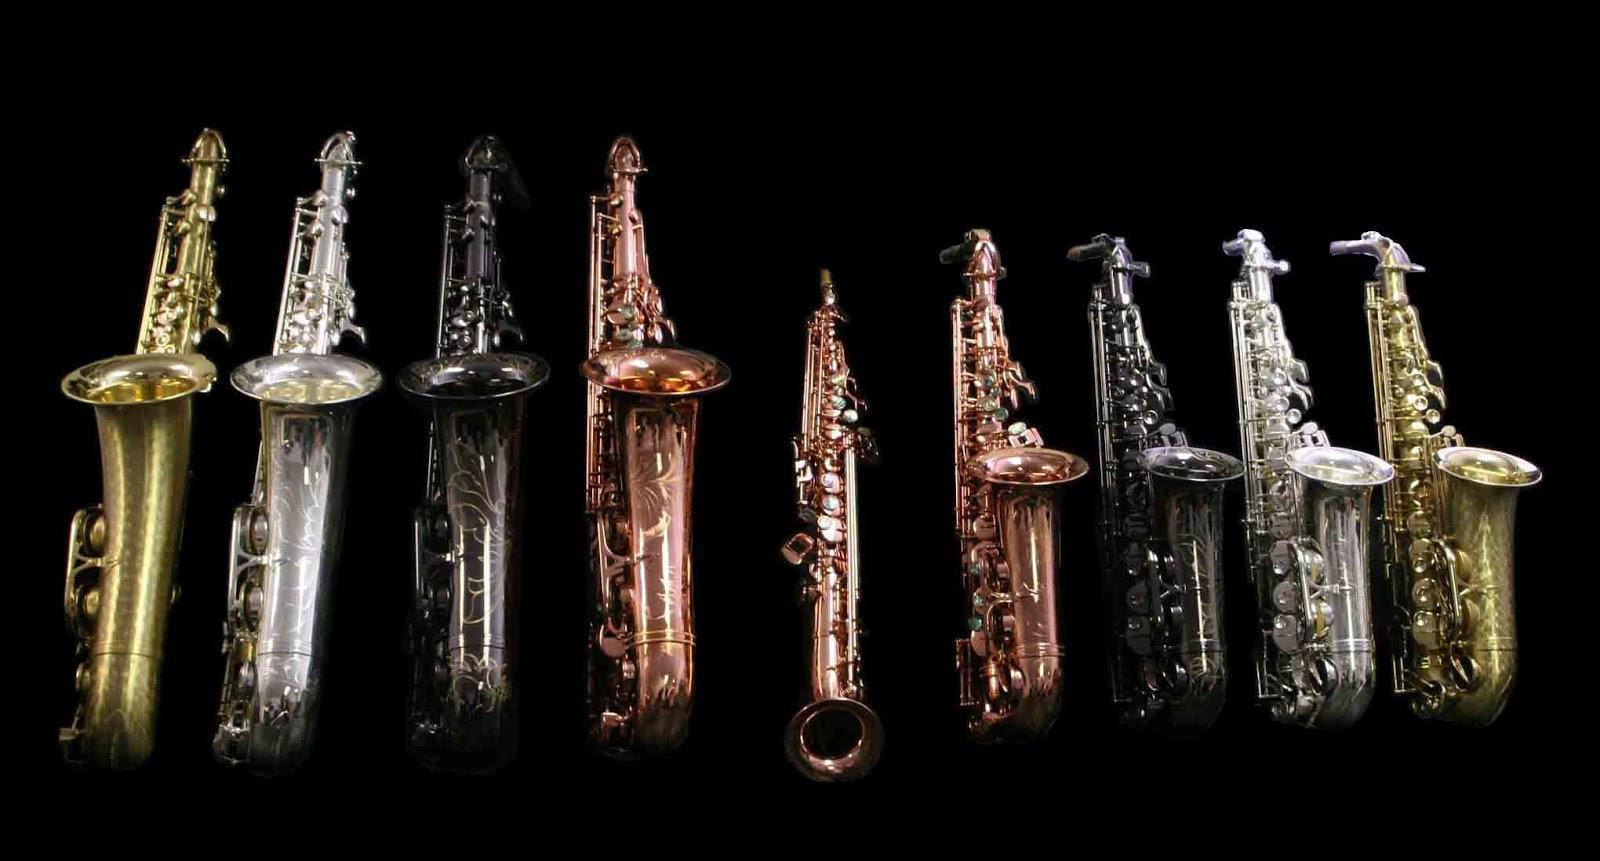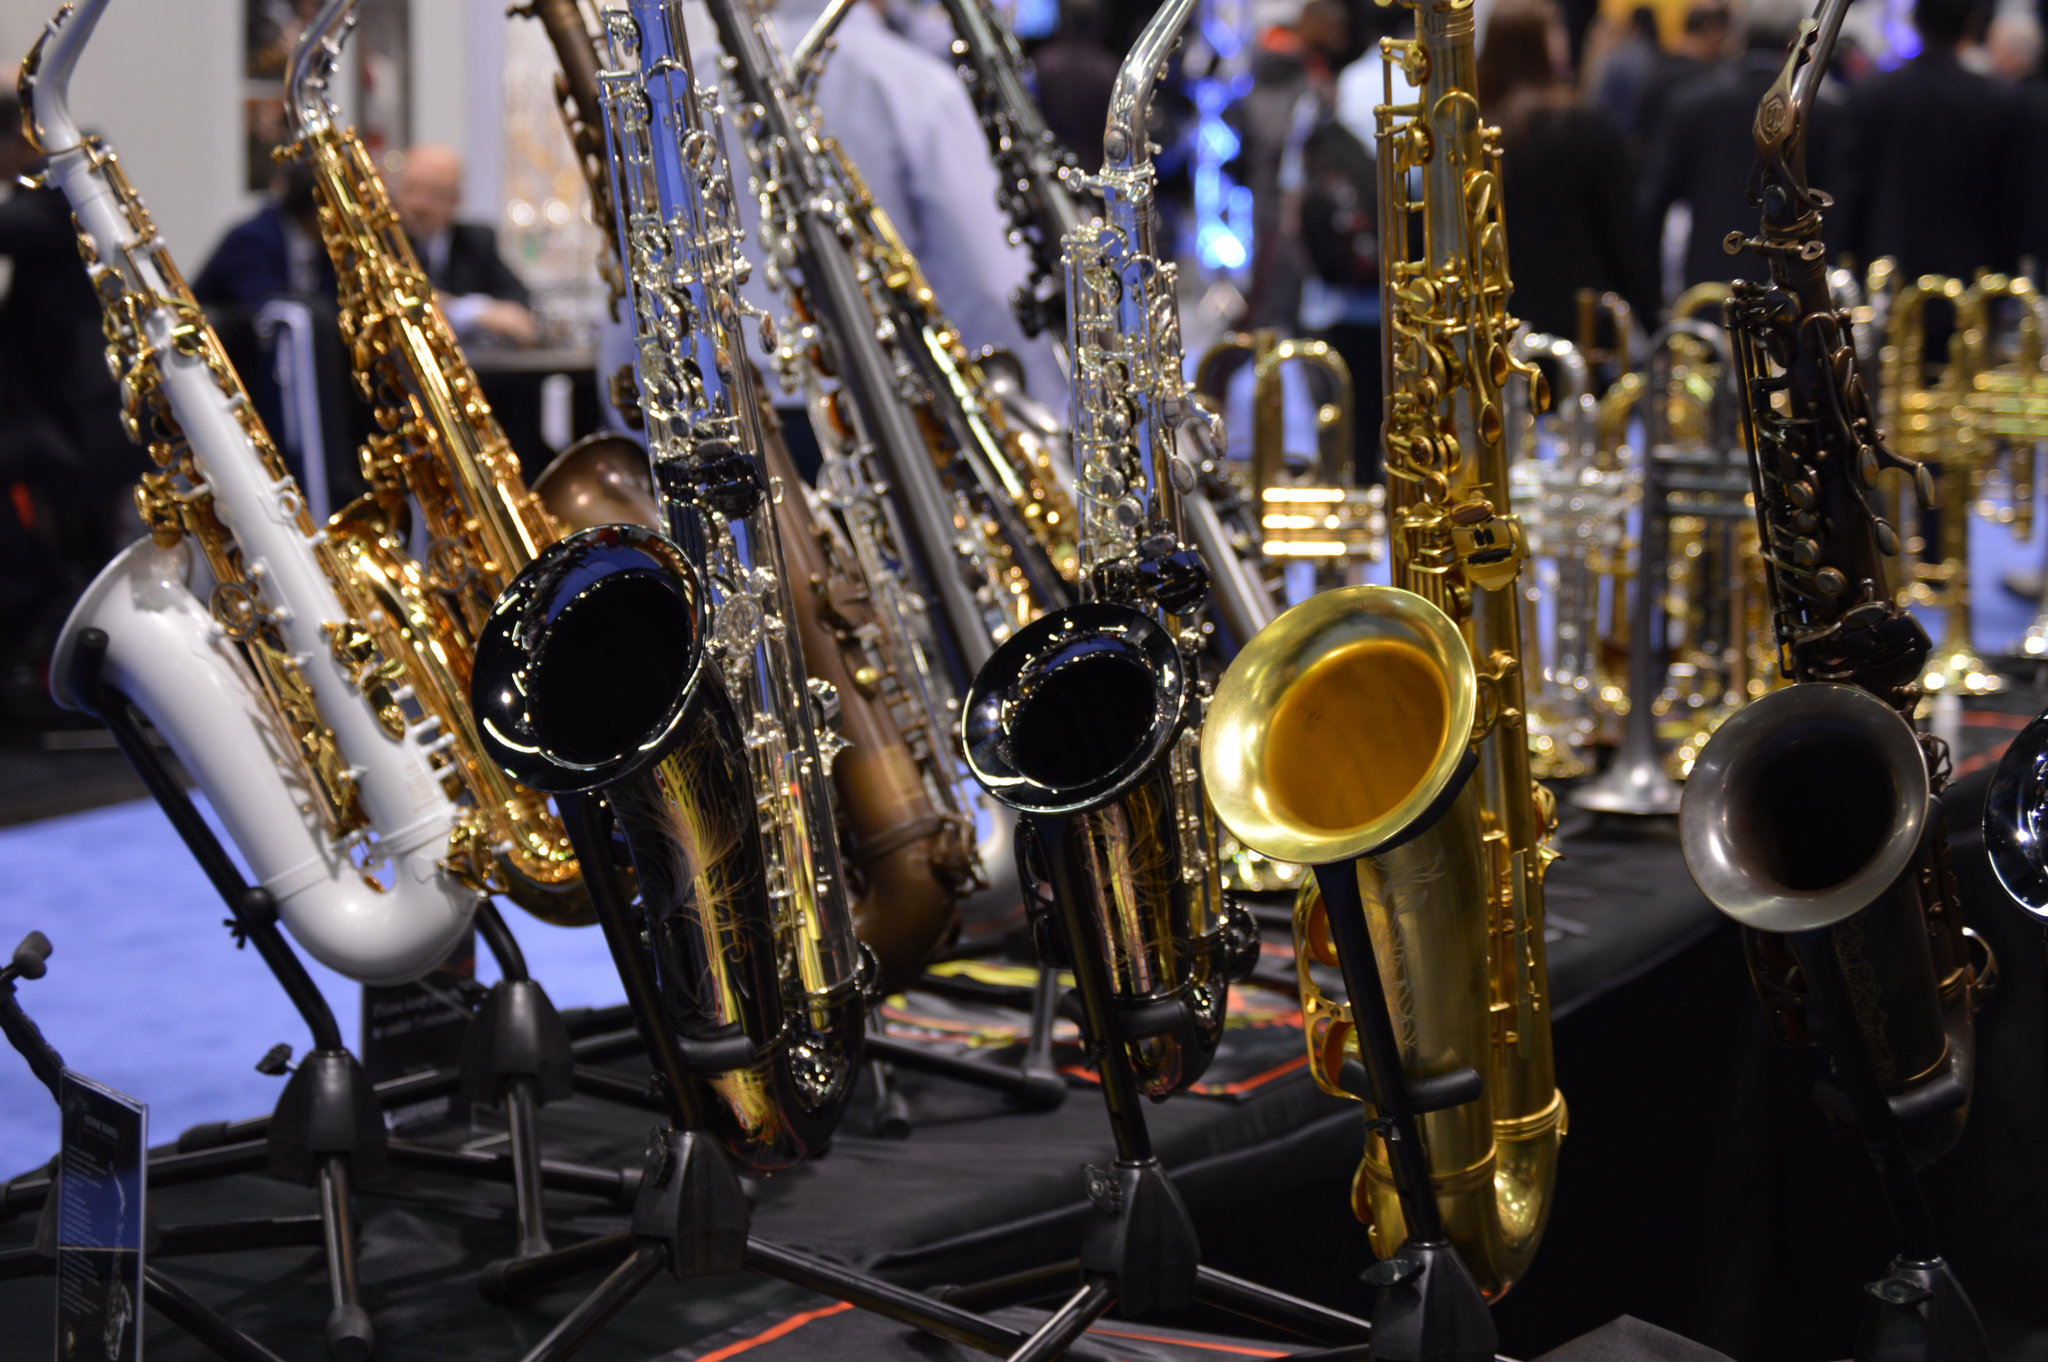The first image is the image on the left, the second image is the image on the right. Considering the images on both sides, is "Right image shows one saxophone and left image shows one row of saxophones." valid? Answer yes or no. No. 